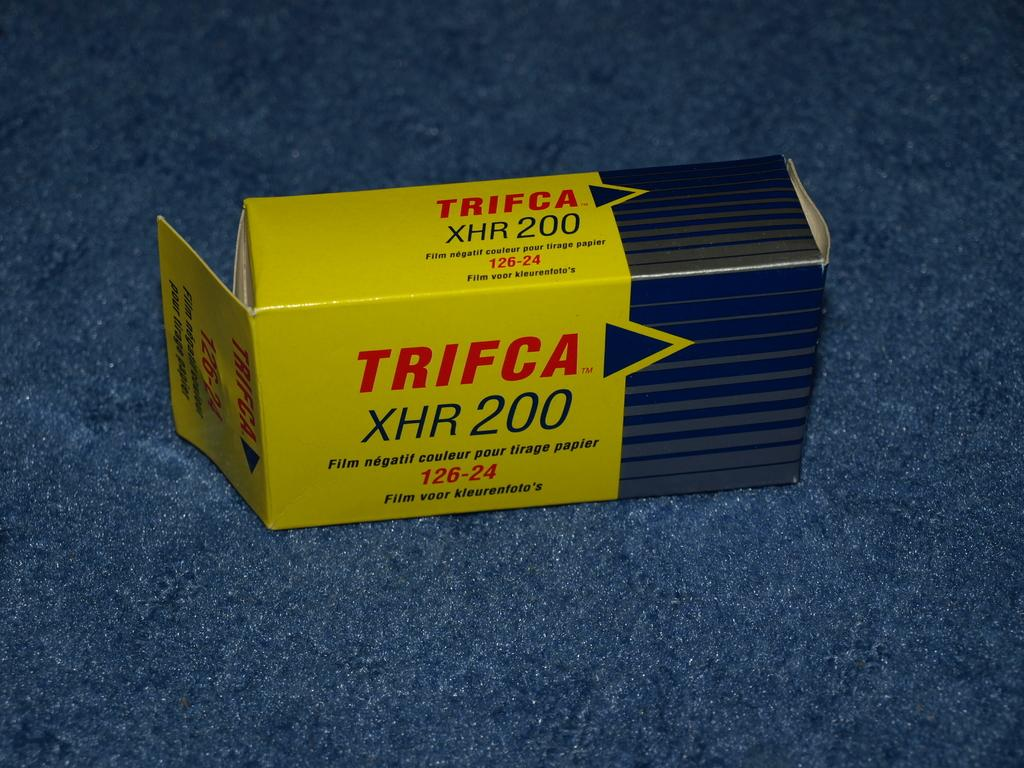What is the main object in the image? There is a box in the image. What can be found on the surface of the box? The box has text and numbers on it. What color is the surface on which the box is placed? The box is on a blue colored surface. How many volleyballs are visible in the image? There are no volleyballs present in the image. What type of flowers can be seen growing near the box in the image? There are no flowers present in the image. 